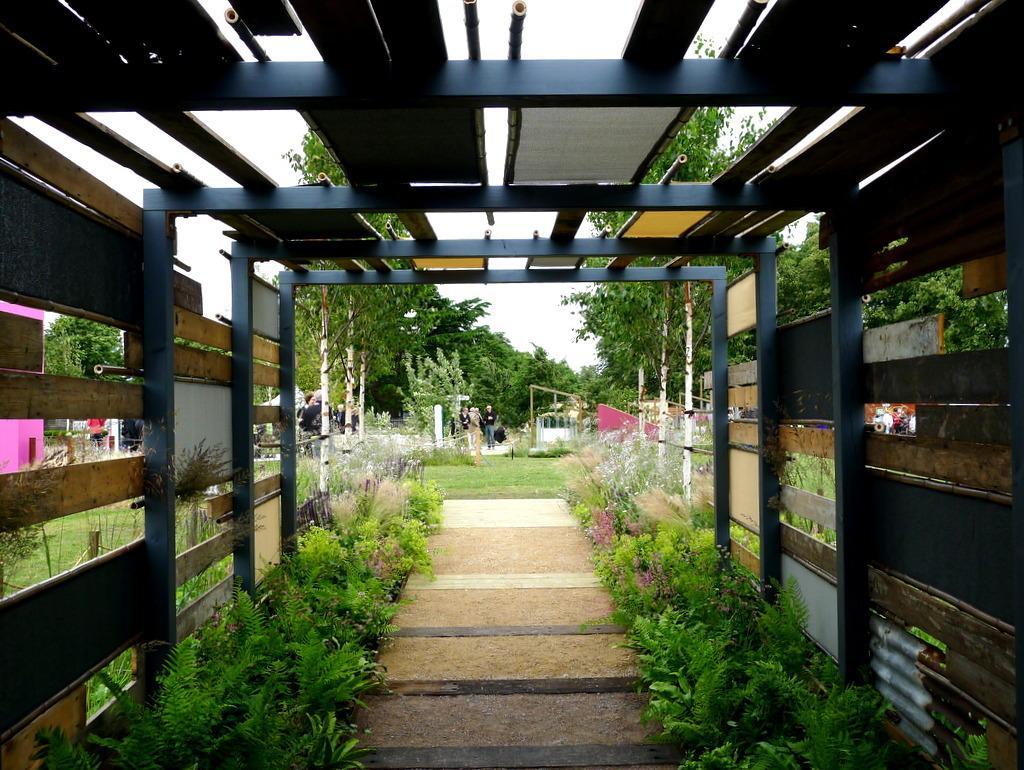Could you give a brief overview of what you see in this image? In this image I can see the path, few plants on both sides of the path, few metal rods, few wooden logs, few trees, few persons standing, some grass and in the background I can see the sky. 